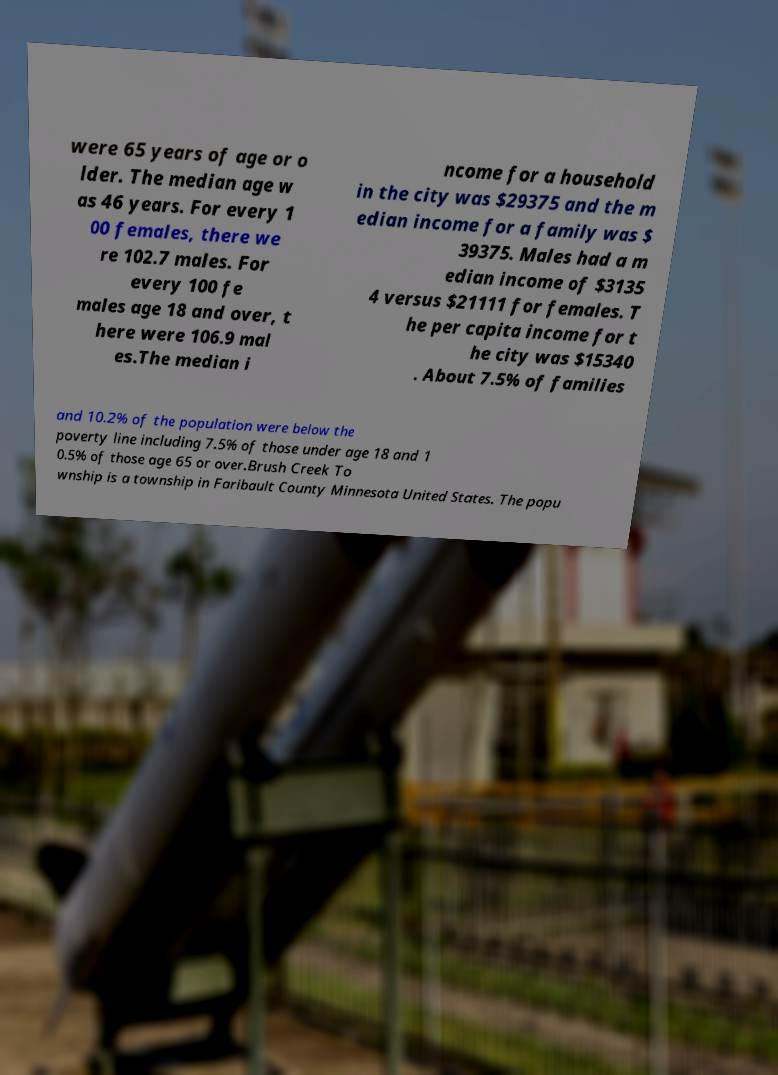There's text embedded in this image that I need extracted. Can you transcribe it verbatim? were 65 years of age or o lder. The median age w as 46 years. For every 1 00 females, there we re 102.7 males. For every 100 fe males age 18 and over, t here were 106.9 mal es.The median i ncome for a household in the city was $29375 and the m edian income for a family was $ 39375. Males had a m edian income of $3135 4 versus $21111 for females. T he per capita income for t he city was $15340 . About 7.5% of families and 10.2% of the population were below the poverty line including 7.5% of those under age 18 and 1 0.5% of those age 65 or over.Brush Creek To wnship is a township in Faribault County Minnesota United States. The popu 